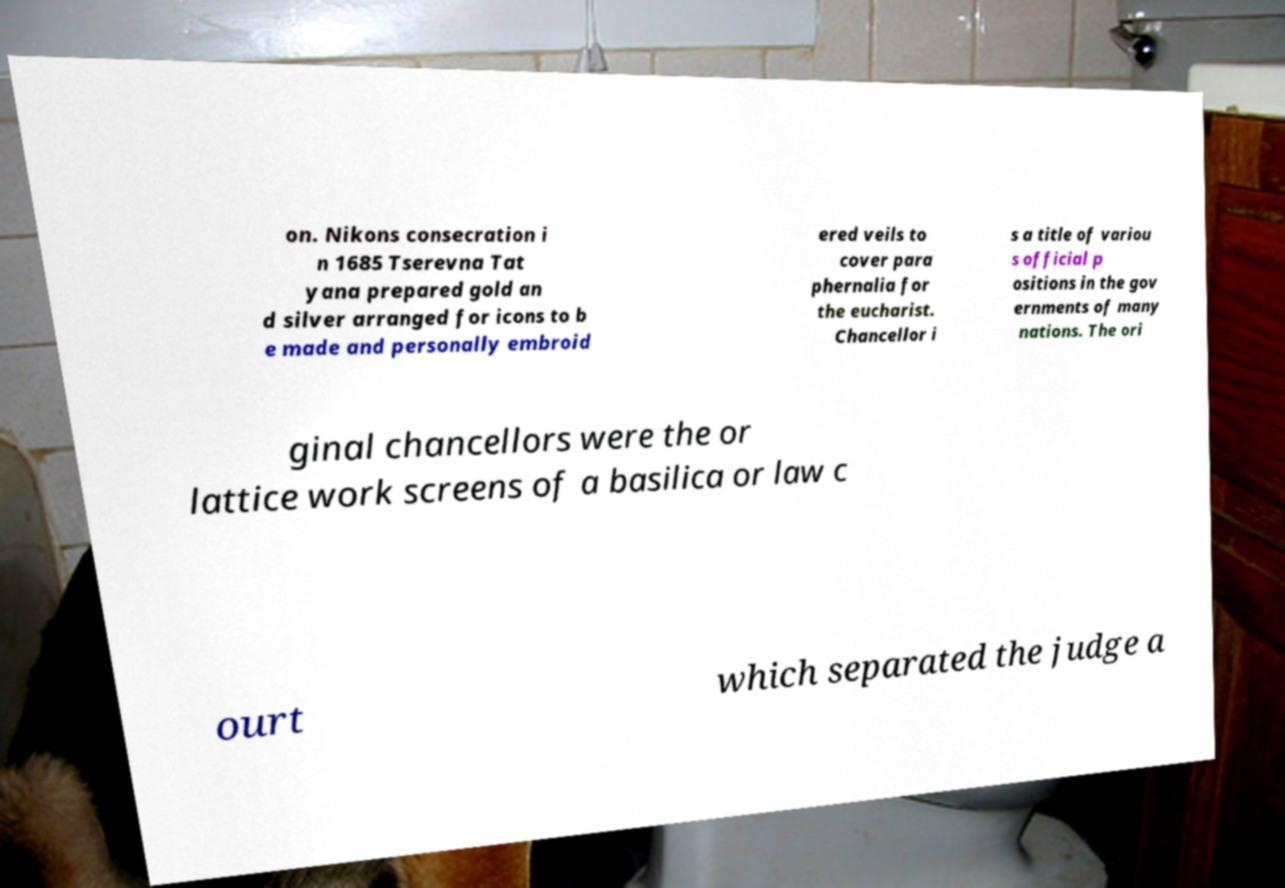Please read and relay the text visible in this image. What does it say? on. Nikons consecration i n 1685 Tserevna Tat yana prepared gold an d silver arranged for icons to b e made and personally embroid ered veils to cover para phernalia for the eucharist. Chancellor i s a title of variou s official p ositions in the gov ernments of many nations. The ori ginal chancellors were the or lattice work screens of a basilica or law c ourt which separated the judge a 